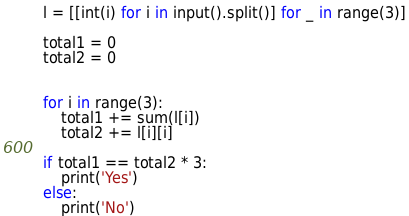<code> <loc_0><loc_0><loc_500><loc_500><_Python_>l = [[int(i) for i in input().split()] for _ in range(3)]

total1 = 0
total2 = 0


for i in range(3):
    total1 += sum(l[i])
    total2 += l[i][i]
    
if total1 == total2 * 3:
    print('Yes')
else:
    print('No')</code> 